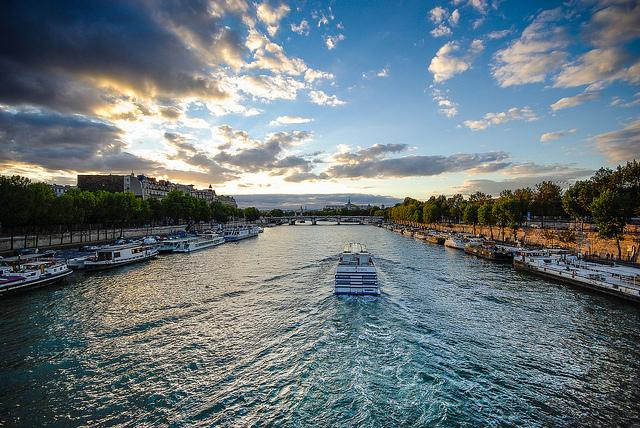What is creating the larger waves? boat 